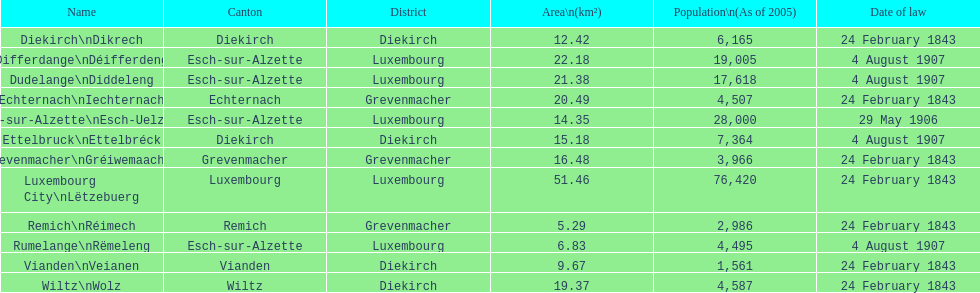How many luxembourg cities had a legal date of february 24, 1843? 7. 